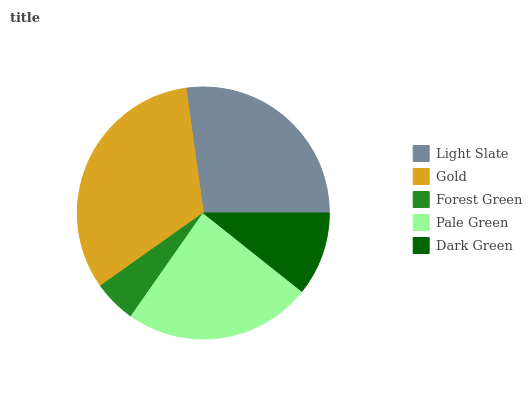Is Forest Green the minimum?
Answer yes or no. Yes. Is Gold the maximum?
Answer yes or no. Yes. Is Gold the minimum?
Answer yes or no. No. Is Forest Green the maximum?
Answer yes or no. No. Is Gold greater than Forest Green?
Answer yes or no. Yes. Is Forest Green less than Gold?
Answer yes or no. Yes. Is Forest Green greater than Gold?
Answer yes or no. No. Is Gold less than Forest Green?
Answer yes or no. No. Is Pale Green the high median?
Answer yes or no. Yes. Is Pale Green the low median?
Answer yes or no. Yes. Is Dark Green the high median?
Answer yes or no. No. Is Forest Green the low median?
Answer yes or no. No. 